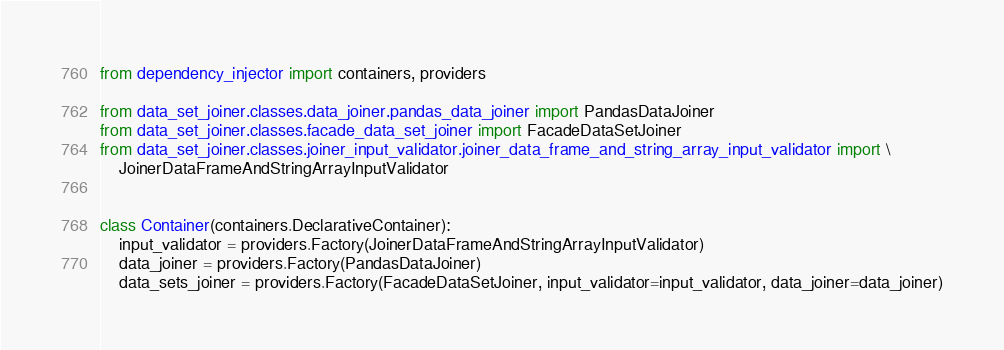<code> <loc_0><loc_0><loc_500><loc_500><_Python_>from dependency_injector import containers, providers

from data_set_joiner.classes.data_joiner.pandas_data_joiner import PandasDataJoiner
from data_set_joiner.classes.facade_data_set_joiner import FacadeDataSetJoiner
from data_set_joiner.classes.joiner_input_validator.joiner_data_frame_and_string_array_input_validator import \
    JoinerDataFrameAndStringArrayInputValidator


class Container(containers.DeclarativeContainer):
    input_validator = providers.Factory(JoinerDataFrameAndStringArrayInputValidator)
    data_joiner = providers.Factory(PandasDataJoiner)
    data_sets_joiner = providers.Factory(FacadeDataSetJoiner, input_validator=input_validator, data_joiner=data_joiner)
</code> 